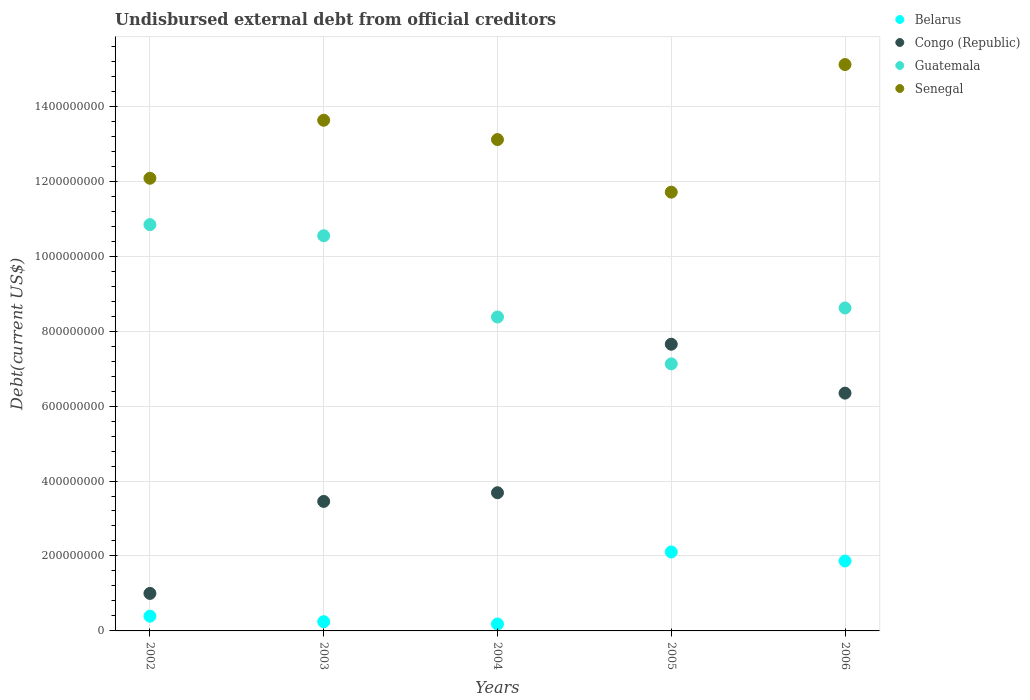How many different coloured dotlines are there?
Provide a short and direct response. 4. Is the number of dotlines equal to the number of legend labels?
Offer a terse response. Yes. What is the total debt in Belarus in 2003?
Ensure brevity in your answer.  2.46e+07. Across all years, what is the maximum total debt in Guatemala?
Offer a terse response. 1.08e+09. Across all years, what is the minimum total debt in Senegal?
Your answer should be compact. 1.17e+09. In which year was the total debt in Belarus minimum?
Your answer should be very brief. 2004. What is the total total debt in Senegal in the graph?
Offer a terse response. 6.56e+09. What is the difference between the total debt in Belarus in 2005 and that in 2006?
Make the answer very short. 2.41e+07. What is the difference between the total debt in Belarus in 2006 and the total debt in Senegal in 2005?
Provide a short and direct response. -9.84e+08. What is the average total debt in Congo (Republic) per year?
Keep it short and to the point. 4.43e+08. In the year 2006, what is the difference between the total debt in Guatemala and total debt in Senegal?
Make the answer very short. -6.50e+08. What is the ratio of the total debt in Guatemala in 2004 to that in 2006?
Your response must be concise. 0.97. What is the difference between the highest and the second highest total debt in Congo (Republic)?
Provide a succinct answer. 1.31e+08. What is the difference between the highest and the lowest total debt in Guatemala?
Offer a terse response. 3.71e+08. Is the sum of the total debt in Congo (Republic) in 2003 and 2004 greater than the maximum total debt in Senegal across all years?
Offer a very short reply. No. Is it the case that in every year, the sum of the total debt in Guatemala and total debt in Senegal  is greater than the sum of total debt in Belarus and total debt in Congo (Republic)?
Your answer should be very brief. No. Are the values on the major ticks of Y-axis written in scientific E-notation?
Your answer should be very brief. No. Does the graph contain grids?
Offer a very short reply. Yes. Where does the legend appear in the graph?
Provide a succinct answer. Top right. How are the legend labels stacked?
Provide a short and direct response. Vertical. What is the title of the graph?
Provide a succinct answer. Undisbursed external debt from official creditors. What is the label or title of the Y-axis?
Offer a terse response. Debt(current US$). What is the Debt(current US$) in Belarus in 2002?
Provide a short and direct response. 3.94e+07. What is the Debt(current US$) in Congo (Republic) in 2002?
Keep it short and to the point. 1.00e+08. What is the Debt(current US$) in Guatemala in 2002?
Offer a terse response. 1.08e+09. What is the Debt(current US$) of Senegal in 2002?
Offer a terse response. 1.21e+09. What is the Debt(current US$) in Belarus in 2003?
Provide a succinct answer. 2.46e+07. What is the Debt(current US$) of Congo (Republic) in 2003?
Make the answer very short. 3.46e+08. What is the Debt(current US$) of Guatemala in 2003?
Provide a succinct answer. 1.05e+09. What is the Debt(current US$) of Senegal in 2003?
Your response must be concise. 1.36e+09. What is the Debt(current US$) in Belarus in 2004?
Provide a short and direct response. 1.84e+07. What is the Debt(current US$) of Congo (Republic) in 2004?
Provide a short and direct response. 3.69e+08. What is the Debt(current US$) in Guatemala in 2004?
Provide a succinct answer. 8.38e+08. What is the Debt(current US$) of Senegal in 2004?
Offer a terse response. 1.31e+09. What is the Debt(current US$) of Belarus in 2005?
Give a very brief answer. 2.11e+08. What is the Debt(current US$) of Congo (Republic) in 2005?
Your response must be concise. 7.65e+08. What is the Debt(current US$) in Guatemala in 2005?
Make the answer very short. 7.13e+08. What is the Debt(current US$) of Senegal in 2005?
Provide a succinct answer. 1.17e+09. What is the Debt(current US$) in Belarus in 2006?
Your answer should be very brief. 1.87e+08. What is the Debt(current US$) in Congo (Republic) in 2006?
Give a very brief answer. 6.35e+08. What is the Debt(current US$) of Guatemala in 2006?
Ensure brevity in your answer.  8.62e+08. What is the Debt(current US$) in Senegal in 2006?
Your answer should be very brief. 1.51e+09. Across all years, what is the maximum Debt(current US$) in Belarus?
Offer a very short reply. 2.11e+08. Across all years, what is the maximum Debt(current US$) of Congo (Republic)?
Your response must be concise. 7.65e+08. Across all years, what is the maximum Debt(current US$) in Guatemala?
Ensure brevity in your answer.  1.08e+09. Across all years, what is the maximum Debt(current US$) in Senegal?
Give a very brief answer. 1.51e+09. Across all years, what is the minimum Debt(current US$) in Belarus?
Ensure brevity in your answer.  1.84e+07. Across all years, what is the minimum Debt(current US$) in Congo (Republic)?
Your answer should be very brief. 1.00e+08. Across all years, what is the minimum Debt(current US$) of Guatemala?
Give a very brief answer. 7.13e+08. Across all years, what is the minimum Debt(current US$) of Senegal?
Provide a short and direct response. 1.17e+09. What is the total Debt(current US$) in Belarus in the graph?
Your response must be concise. 4.80e+08. What is the total Debt(current US$) of Congo (Republic) in the graph?
Your answer should be compact. 2.21e+09. What is the total Debt(current US$) in Guatemala in the graph?
Your answer should be compact. 4.55e+09. What is the total Debt(current US$) of Senegal in the graph?
Keep it short and to the point. 6.56e+09. What is the difference between the Debt(current US$) of Belarus in 2002 and that in 2003?
Your answer should be compact. 1.48e+07. What is the difference between the Debt(current US$) in Congo (Republic) in 2002 and that in 2003?
Your response must be concise. -2.45e+08. What is the difference between the Debt(current US$) of Guatemala in 2002 and that in 2003?
Offer a very short reply. 2.96e+07. What is the difference between the Debt(current US$) of Senegal in 2002 and that in 2003?
Offer a very short reply. -1.55e+08. What is the difference between the Debt(current US$) of Belarus in 2002 and that in 2004?
Provide a short and direct response. 2.10e+07. What is the difference between the Debt(current US$) in Congo (Republic) in 2002 and that in 2004?
Provide a succinct answer. -2.69e+08. What is the difference between the Debt(current US$) in Guatemala in 2002 and that in 2004?
Give a very brief answer. 2.46e+08. What is the difference between the Debt(current US$) of Senegal in 2002 and that in 2004?
Ensure brevity in your answer.  -1.03e+08. What is the difference between the Debt(current US$) in Belarus in 2002 and that in 2005?
Ensure brevity in your answer.  -1.71e+08. What is the difference between the Debt(current US$) of Congo (Republic) in 2002 and that in 2005?
Your response must be concise. -6.65e+08. What is the difference between the Debt(current US$) of Guatemala in 2002 and that in 2005?
Your response must be concise. 3.71e+08. What is the difference between the Debt(current US$) of Senegal in 2002 and that in 2005?
Provide a short and direct response. 3.71e+07. What is the difference between the Debt(current US$) in Belarus in 2002 and that in 2006?
Offer a very short reply. -1.47e+08. What is the difference between the Debt(current US$) of Congo (Republic) in 2002 and that in 2006?
Your answer should be very brief. -5.34e+08. What is the difference between the Debt(current US$) in Guatemala in 2002 and that in 2006?
Make the answer very short. 2.22e+08. What is the difference between the Debt(current US$) in Senegal in 2002 and that in 2006?
Provide a short and direct response. -3.03e+08. What is the difference between the Debt(current US$) of Belarus in 2003 and that in 2004?
Offer a terse response. 6.18e+06. What is the difference between the Debt(current US$) of Congo (Republic) in 2003 and that in 2004?
Your answer should be very brief. -2.32e+07. What is the difference between the Debt(current US$) in Guatemala in 2003 and that in 2004?
Provide a succinct answer. 2.17e+08. What is the difference between the Debt(current US$) of Senegal in 2003 and that in 2004?
Keep it short and to the point. 5.16e+07. What is the difference between the Debt(current US$) of Belarus in 2003 and that in 2005?
Provide a succinct answer. -1.86e+08. What is the difference between the Debt(current US$) of Congo (Republic) in 2003 and that in 2005?
Give a very brief answer. -4.19e+08. What is the difference between the Debt(current US$) in Guatemala in 2003 and that in 2005?
Offer a very short reply. 3.42e+08. What is the difference between the Debt(current US$) of Senegal in 2003 and that in 2005?
Give a very brief answer. 1.92e+08. What is the difference between the Debt(current US$) in Belarus in 2003 and that in 2006?
Ensure brevity in your answer.  -1.62e+08. What is the difference between the Debt(current US$) of Congo (Republic) in 2003 and that in 2006?
Ensure brevity in your answer.  -2.89e+08. What is the difference between the Debt(current US$) of Guatemala in 2003 and that in 2006?
Offer a terse response. 1.93e+08. What is the difference between the Debt(current US$) of Senegal in 2003 and that in 2006?
Provide a succinct answer. -1.49e+08. What is the difference between the Debt(current US$) of Belarus in 2004 and that in 2005?
Provide a succinct answer. -1.92e+08. What is the difference between the Debt(current US$) in Congo (Republic) in 2004 and that in 2005?
Offer a very short reply. -3.96e+08. What is the difference between the Debt(current US$) in Guatemala in 2004 and that in 2005?
Keep it short and to the point. 1.25e+08. What is the difference between the Debt(current US$) of Senegal in 2004 and that in 2005?
Your response must be concise. 1.40e+08. What is the difference between the Debt(current US$) in Belarus in 2004 and that in 2006?
Your answer should be very brief. -1.68e+08. What is the difference between the Debt(current US$) of Congo (Republic) in 2004 and that in 2006?
Your answer should be very brief. -2.66e+08. What is the difference between the Debt(current US$) in Guatemala in 2004 and that in 2006?
Give a very brief answer. -2.40e+07. What is the difference between the Debt(current US$) in Senegal in 2004 and that in 2006?
Your response must be concise. -2.00e+08. What is the difference between the Debt(current US$) in Belarus in 2005 and that in 2006?
Offer a terse response. 2.41e+07. What is the difference between the Debt(current US$) of Congo (Republic) in 2005 and that in 2006?
Your answer should be compact. 1.31e+08. What is the difference between the Debt(current US$) in Guatemala in 2005 and that in 2006?
Provide a short and direct response. -1.49e+08. What is the difference between the Debt(current US$) of Senegal in 2005 and that in 2006?
Offer a very short reply. -3.40e+08. What is the difference between the Debt(current US$) in Belarus in 2002 and the Debt(current US$) in Congo (Republic) in 2003?
Offer a very short reply. -3.06e+08. What is the difference between the Debt(current US$) of Belarus in 2002 and the Debt(current US$) of Guatemala in 2003?
Offer a terse response. -1.02e+09. What is the difference between the Debt(current US$) of Belarus in 2002 and the Debt(current US$) of Senegal in 2003?
Provide a succinct answer. -1.32e+09. What is the difference between the Debt(current US$) in Congo (Republic) in 2002 and the Debt(current US$) in Guatemala in 2003?
Your answer should be very brief. -9.54e+08. What is the difference between the Debt(current US$) in Congo (Republic) in 2002 and the Debt(current US$) in Senegal in 2003?
Ensure brevity in your answer.  -1.26e+09. What is the difference between the Debt(current US$) of Guatemala in 2002 and the Debt(current US$) of Senegal in 2003?
Your answer should be compact. -2.79e+08. What is the difference between the Debt(current US$) in Belarus in 2002 and the Debt(current US$) in Congo (Republic) in 2004?
Offer a terse response. -3.29e+08. What is the difference between the Debt(current US$) in Belarus in 2002 and the Debt(current US$) in Guatemala in 2004?
Your answer should be very brief. -7.98e+08. What is the difference between the Debt(current US$) in Belarus in 2002 and the Debt(current US$) in Senegal in 2004?
Provide a succinct answer. -1.27e+09. What is the difference between the Debt(current US$) in Congo (Republic) in 2002 and the Debt(current US$) in Guatemala in 2004?
Your answer should be compact. -7.38e+08. What is the difference between the Debt(current US$) of Congo (Republic) in 2002 and the Debt(current US$) of Senegal in 2004?
Your answer should be very brief. -1.21e+09. What is the difference between the Debt(current US$) of Guatemala in 2002 and the Debt(current US$) of Senegal in 2004?
Keep it short and to the point. -2.27e+08. What is the difference between the Debt(current US$) in Belarus in 2002 and the Debt(current US$) in Congo (Republic) in 2005?
Your answer should be very brief. -7.26e+08. What is the difference between the Debt(current US$) of Belarus in 2002 and the Debt(current US$) of Guatemala in 2005?
Offer a terse response. -6.73e+08. What is the difference between the Debt(current US$) in Belarus in 2002 and the Debt(current US$) in Senegal in 2005?
Your answer should be very brief. -1.13e+09. What is the difference between the Debt(current US$) in Congo (Republic) in 2002 and the Debt(current US$) in Guatemala in 2005?
Make the answer very short. -6.13e+08. What is the difference between the Debt(current US$) of Congo (Republic) in 2002 and the Debt(current US$) of Senegal in 2005?
Offer a very short reply. -1.07e+09. What is the difference between the Debt(current US$) of Guatemala in 2002 and the Debt(current US$) of Senegal in 2005?
Your response must be concise. -8.67e+07. What is the difference between the Debt(current US$) in Belarus in 2002 and the Debt(current US$) in Congo (Republic) in 2006?
Ensure brevity in your answer.  -5.95e+08. What is the difference between the Debt(current US$) in Belarus in 2002 and the Debt(current US$) in Guatemala in 2006?
Keep it short and to the point. -8.22e+08. What is the difference between the Debt(current US$) in Belarus in 2002 and the Debt(current US$) in Senegal in 2006?
Ensure brevity in your answer.  -1.47e+09. What is the difference between the Debt(current US$) in Congo (Republic) in 2002 and the Debt(current US$) in Guatemala in 2006?
Keep it short and to the point. -7.62e+08. What is the difference between the Debt(current US$) of Congo (Republic) in 2002 and the Debt(current US$) of Senegal in 2006?
Your response must be concise. -1.41e+09. What is the difference between the Debt(current US$) in Guatemala in 2002 and the Debt(current US$) in Senegal in 2006?
Your response must be concise. -4.27e+08. What is the difference between the Debt(current US$) of Belarus in 2003 and the Debt(current US$) of Congo (Republic) in 2004?
Ensure brevity in your answer.  -3.44e+08. What is the difference between the Debt(current US$) of Belarus in 2003 and the Debt(current US$) of Guatemala in 2004?
Ensure brevity in your answer.  -8.13e+08. What is the difference between the Debt(current US$) of Belarus in 2003 and the Debt(current US$) of Senegal in 2004?
Offer a very short reply. -1.29e+09. What is the difference between the Debt(current US$) in Congo (Republic) in 2003 and the Debt(current US$) in Guatemala in 2004?
Your answer should be very brief. -4.92e+08. What is the difference between the Debt(current US$) of Congo (Republic) in 2003 and the Debt(current US$) of Senegal in 2004?
Your response must be concise. -9.66e+08. What is the difference between the Debt(current US$) of Guatemala in 2003 and the Debt(current US$) of Senegal in 2004?
Offer a terse response. -2.57e+08. What is the difference between the Debt(current US$) in Belarus in 2003 and the Debt(current US$) in Congo (Republic) in 2005?
Make the answer very short. -7.40e+08. What is the difference between the Debt(current US$) of Belarus in 2003 and the Debt(current US$) of Guatemala in 2005?
Offer a very short reply. -6.88e+08. What is the difference between the Debt(current US$) of Belarus in 2003 and the Debt(current US$) of Senegal in 2005?
Provide a succinct answer. -1.15e+09. What is the difference between the Debt(current US$) of Congo (Republic) in 2003 and the Debt(current US$) of Guatemala in 2005?
Offer a terse response. -3.67e+08. What is the difference between the Debt(current US$) in Congo (Republic) in 2003 and the Debt(current US$) in Senegal in 2005?
Give a very brief answer. -8.25e+08. What is the difference between the Debt(current US$) in Guatemala in 2003 and the Debt(current US$) in Senegal in 2005?
Ensure brevity in your answer.  -1.16e+08. What is the difference between the Debt(current US$) in Belarus in 2003 and the Debt(current US$) in Congo (Republic) in 2006?
Offer a very short reply. -6.10e+08. What is the difference between the Debt(current US$) in Belarus in 2003 and the Debt(current US$) in Guatemala in 2006?
Your answer should be compact. -8.37e+08. What is the difference between the Debt(current US$) of Belarus in 2003 and the Debt(current US$) of Senegal in 2006?
Your answer should be compact. -1.49e+09. What is the difference between the Debt(current US$) of Congo (Republic) in 2003 and the Debt(current US$) of Guatemala in 2006?
Make the answer very short. -5.16e+08. What is the difference between the Debt(current US$) in Congo (Republic) in 2003 and the Debt(current US$) in Senegal in 2006?
Make the answer very short. -1.17e+09. What is the difference between the Debt(current US$) of Guatemala in 2003 and the Debt(current US$) of Senegal in 2006?
Keep it short and to the point. -4.57e+08. What is the difference between the Debt(current US$) in Belarus in 2004 and the Debt(current US$) in Congo (Republic) in 2005?
Your response must be concise. -7.47e+08. What is the difference between the Debt(current US$) of Belarus in 2004 and the Debt(current US$) of Guatemala in 2005?
Provide a succinct answer. -6.94e+08. What is the difference between the Debt(current US$) in Belarus in 2004 and the Debt(current US$) in Senegal in 2005?
Keep it short and to the point. -1.15e+09. What is the difference between the Debt(current US$) in Congo (Republic) in 2004 and the Debt(current US$) in Guatemala in 2005?
Offer a terse response. -3.44e+08. What is the difference between the Debt(current US$) in Congo (Republic) in 2004 and the Debt(current US$) in Senegal in 2005?
Your answer should be very brief. -8.02e+08. What is the difference between the Debt(current US$) of Guatemala in 2004 and the Debt(current US$) of Senegal in 2005?
Offer a terse response. -3.33e+08. What is the difference between the Debt(current US$) of Belarus in 2004 and the Debt(current US$) of Congo (Republic) in 2006?
Your answer should be very brief. -6.16e+08. What is the difference between the Debt(current US$) in Belarus in 2004 and the Debt(current US$) in Guatemala in 2006?
Keep it short and to the point. -8.43e+08. What is the difference between the Debt(current US$) of Belarus in 2004 and the Debt(current US$) of Senegal in 2006?
Keep it short and to the point. -1.49e+09. What is the difference between the Debt(current US$) of Congo (Republic) in 2004 and the Debt(current US$) of Guatemala in 2006?
Provide a short and direct response. -4.93e+08. What is the difference between the Debt(current US$) in Congo (Republic) in 2004 and the Debt(current US$) in Senegal in 2006?
Your answer should be compact. -1.14e+09. What is the difference between the Debt(current US$) in Guatemala in 2004 and the Debt(current US$) in Senegal in 2006?
Offer a terse response. -6.74e+08. What is the difference between the Debt(current US$) in Belarus in 2005 and the Debt(current US$) in Congo (Republic) in 2006?
Ensure brevity in your answer.  -4.24e+08. What is the difference between the Debt(current US$) in Belarus in 2005 and the Debt(current US$) in Guatemala in 2006?
Provide a succinct answer. -6.51e+08. What is the difference between the Debt(current US$) of Belarus in 2005 and the Debt(current US$) of Senegal in 2006?
Offer a very short reply. -1.30e+09. What is the difference between the Debt(current US$) of Congo (Republic) in 2005 and the Debt(current US$) of Guatemala in 2006?
Offer a terse response. -9.67e+07. What is the difference between the Debt(current US$) of Congo (Republic) in 2005 and the Debt(current US$) of Senegal in 2006?
Provide a short and direct response. -7.46e+08. What is the difference between the Debt(current US$) in Guatemala in 2005 and the Debt(current US$) in Senegal in 2006?
Your answer should be compact. -7.99e+08. What is the average Debt(current US$) of Belarus per year?
Provide a short and direct response. 9.59e+07. What is the average Debt(current US$) of Congo (Republic) per year?
Provide a succinct answer. 4.43e+08. What is the average Debt(current US$) of Guatemala per year?
Offer a very short reply. 9.10e+08. What is the average Debt(current US$) in Senegal per year?
Offer a terse response. 1.31e+09. In the year 2002, what is the difference between the Debt(current US$) of Belarus and Debt(current US$) of Congo (Republic)?
Provide a succinct answer. -6.07e+07. In the year 2002, what is the difference between the Debt(current US$) in Belarus and Debt(current US$) in Guatemala?
Provide a succinct answer. -1.04e+09. In the year 2002, what is the difference between the Debt(current US$) of Belarus and Debt(current US$) of Senegal?
Provide a short and direct response. -1.17e+09. In the year 2002, what is the difference between the Debt(current US$) of Congo (Republic) and Debt(current US$) of Guatemala?
Make the answer very short. -9.84e+08. In the year 2002, what is the difference between the Debt(current US$) of Congo (Republic) and Debt(current US$) of Senegal?
Your answer should be compact. -1.11e+09. In the year 2002, what is the difference between the Debt(current US$) in Guatemala and Debt(current US$) in Senegal?
Offer a terse response. -1.24e+08. In the year 2003, what is the difference between the Debt(current US$) of Belarus and Debt(current US$) of Congo (Republic)?
Offer a terse response. -3.21e+08. In the year 2003, what is the difference between the Debt(current US$) in Belarus and Debt(current US$) in Guatemala?
Your response must be concise. -1.03e+09. In the year 2003, what is the difference between the Debt(current US$) in Belarus and Debt(current US$) in Senegal?
Provide a succinct answer. -1.34e+09. In the year 2003, what is the difference between the Debt(current US$) in Congo (Republic) and Debt(current US$) in Guatemala?
Ensure brevity in your answer.  -7.09e+08. In the year 2003, what is the difference between the Debt(current US$) in Congo (Republic) and Debt(current US$) in Senegal?
Your answer should be very brief. -1.02e+09. In the year 2003, what is the difference between the Debt(current US$) in Guatemala and Debt(current US$) in Senegal?
Provide a short and direct response. -3.08e+08. In the year 2004, what is the difference between the Debt(current US$) in Belarus and Debt(current US$) in Congo (Republic)?
Keep it short and to the point. -3.50e+08. In the year 2004, what is the difference between the Debt(current US$) of Belarus and Debt(current US$) of Guatemala?
Offer a very short reply. -8.19e+08. In the year 2004, what is the difference between the Debt(current US$) of Belarus and Debt(current US$) of Senegal?
Offer a terse response. -1.29e+09. In the year 2004, what is the difference between the Debt(current US$) of Congo (Republic) and Debt(current US$) of Guatemala?
Make the answer very short. -4.69e+08. In the year 2004, what is the difference between the Debt(current US$) in Congo (Republic) and Debt(current US$) in Senegal?
Your response must be concise. -9.42e+08. In the year 2004, what is the difference between the Debt(current US$) in Guatemala and Debt(current US$) in Senegal?
Your response must be concise. -4.73e+08. In the year 2005, what is the difference between the Debt(current US$) of Belarus and Debt(current US$) of Congo (Republic)?
Make the answer very short. -5.54e+08. In the year 2005, what is the difference between the Debt(current US$) of Belarus and Debt(current US$) of Guatemala?
Offer a terse response. -5.02e+08. In the year 2005, what is the difference between the Debt(current US$) in Belarus and Debt(current US$) in Senegal?
Ensure brevity in your answer.  -9.60e+08. In the year 2005, what is the difference between the Debt(current US$) in Congo (Republic) and Debt(current US$) in Guatemala?
Ensure brevity in your answer.  5.24e+07. In the year 2005, what is the difference between the Debt(current US$) in Congo (Republic) and Debt(current US$) in Senegal?
Your response must be concise. -4.06e+08. In the year 2005, what is the difference between the Debt(current US$) in Guatemala and Debt(current US$) in Senegal?
Provide a short and direct response. -4.58e+08. In the year 2006, what is the difference between the Debt(current US$) in Belarus and Debt(current US$) in Congo (Republic)?
Provide a succinct answer. -4.48e+08. In the year 2006, what is the difference between the Debt(current US$) of Belarus and Debt(current US$) of Guatemala?
Your answer should be very brief. -6.75e+08. In the year 2006, what is the difference between the Debt(current US$) in Belarus and Debt(current US$) in Senegal?
Your response must be concise. -1.32e+09. In the year 2006, what is the difference between the Debt(current US$) in Congo (Republic) and Debt(current US$) in Guatemala?
Your answer should be compact. -2.27e+08. In the year 2006, what is the difference between the Debt(current US$) in Congo (Republic) and Debt(current US$) in Senegal?
Provide a short and direct response. -8.77e+08. In the year 2006, what is the difference between the Debt(current US$) of Guatemala and Debt(current US$) of Senegal?
Make the answer very short. -6.50e+08. What is the ratio of the Debt(current US$) in Belarus in 2002 to that in 2003?
Provide a succinct answer. 1.6. What is the ratio of the Debt(current US$) of Congo (Republic) in 2002 to that in 2003?
Make the answer very short. 0.29. What is the ratio of the Debt(current US$) in Guatemala in 2002 to that in 2003?
Your response must be concise. 1.03. What is the ratio of the Debt(current US$) in Senegal in 2002 to that in 2003?
Provide a succinct answer. 0.89. What is the ratio of the Debt(current US$) in Belarus in 2002 to that in 2004?
Keep it short and to the point. 2.14. What is the ratio of the Debt(current US$) of Congo (Republic) in 2002 to that in 2004?
Keep it short and to the point. 0.27. What is the ratio of the Debt(current US$) in Guatemala in 2002 to that in 2004?
Offer a very short reply. 1.29. What is the ratio of the Debt(current US$) in Senegal in 2002 to that in 2004?
Your response must be concise. 0.92. What is the ratio of the Debt(current US$) in Belarus in 2002 to that in 2005?
Give a very brief answer. 0.19. What is the ratio of the Debt(current US$) of Congo (Republic) in 2002 to that in 2005?
Your answer should be very brief. 0.13. What is the ratio of the Debt(current US$) in Guatemala in 2002 to that in 2005?
Your answer should be compact. 1.52. What is the ratio of the Debt(current US$) of Senegal in 2002 to that in 2005?
Provide a succinct answer. 1.03. What is the ratio of the Debt(current US$) in Belarus in 2002 to that in 2006?
Your response must be concise. 0.21. What is the ratio of the Debt(current US$) in Congo (Republic) in 2002 to that in 2006?
Ensure brevity in your answer.  0.16. What is the ratio of the Debt(current US$) in Guatemala in 2002 to that in 2006?
Your answer should be compact. 1.26. What is the ratio of the Debt(current US$) in Senegal in 2002 to that in 2006?
Your response must be concise. 0.8. What is the ratio of the Debt(current US$) of Belarus in 2003 to that in 2004?
Ensure brevity in your answer.  1.34. What is the ratio of the Debt(current US$) of Congo (Republic) in 2003 to that in 2004?
Provide a short and direct response. 0.94. What is the ratio of the Debt(current US$) in Guatemala in 2003 to that in 2004?
Make the answer very short. 1.26. What is the ratio of the Debt(current US$) of Senegal in 2003 to that in 2004?
Your answer should be very brief. 1.04. What is the ratio of the Debt(current US$) in Belarus in 2003 to that in 2005?
Keep it short and to the point. 0.12. What is the ratio of the Debt(current US$) of Congo (Republic) in 2003 to that in 2005?
Keep it short and to the point. 0.45. What is the ratio of the Debt(current US$) in Guatemala in 2003 to that in 2005?
Offer a terse response. 1.48. What is the ratio of the Debt(current US$) of Senegal in 2003 to that in 2005?
Give a very brief answer. 1.16. What is the ratio of the Debt(current US$) in Belarus in 2003 to that in 2006?
Your answer should be compact. 0.13. What is the ratio of the Debt(current US$) of Congo (Republic) in 2003 to that in 2006?
Ensure brevity in your answer.  0.54. What is the ratio of the Debt(current US$) in Guatemala in 2003 to that in 2006?
Ensure brevity in your answer.  1.22. What is the ratio of the Debt(current US$) of Senegal in 2003 to that in 2006?
Provide a succinct answer. 0.9. What is the ratio of the Debt(current US$) of Belarus in 2004 to that in 2005?
Offer a terse response. 0.09. What is the ratio of the Debt(current US$) in Congo (Republic) in 2004 to that in 2005?
Offer a terse response. 0.48. What is the ratio of the Debt(current US$) in Guatemala in 2004 to that in 2005?
Your answer should be very brief. 1.18. What is the ratio of the Debt(current US$) in Senegal in 2004 to that in 2005?
Ensure brevity in your answer.  1.12. What is the ratio of the Debt(current US$) of Belarus in 2004 to that in 2006?
Keep it short and to the point. 0.1. What is the ratio of the Debt(current US$) in Congo (Republic) in 2004 to that in 2006?
Ensure brevity in your answer.  0.58. What is the ratio of the Debt(current US$) of Guatemala in 2004 to that in 2006?
Offer a very short reply. 0.97. What is the ratio of the Debt(current US$) of Senegal in 2004 to that in 2006?
Offer a very short reply. 0.87. What is the ratio of the Debt(current US$) of Belarus in 2005 to that in 2006?
Give a very brief answer. 1.13. What is the ratio of the Debt(current US$) in Congo (Republic) in 2005 to that in 2006?
Offer a terse response. 1.21. What is the ratio of the Debt(current US$) in Guatemala in 2005 to that in 2006?
Provide a succinct answer. 0.83. What is the ratio of the Debt(current US$) of Senegal in 2005 to that in 2006?
Offer a very short reply. 0.77. What is the difference between the highest and the second highest Debt(current US$) in Belarus?
Your answer should be very brief. 2.41e+07. What is the difference between the highest and the second highest Debt(current US$) of Congo (Republic)?
Make the answer very short. 1.31e+08. What is the difference between the highest and the second highest Debt(current US$) in Guatemala?
Provide a succinct answer. 2.96e+07. What is the difference between the highest and the second highest Debt(current US$) of Senegal?
Ensure brevity in your answer.  1.49e+08. What is the difference between the highest and the lowest Debt(current US$) in Belarus?
Your answer should be compact. 1.92e+08. What is the difference between the highest and the lowest Debt(current US$) in Congo (Republic)?
Your response must be concise. 6.65e+08. What is the difference between the highest and the lowest Debt(current US$) in Guatemala?
Keep it short and to the point. 3.71e+08. What is the difference between the highest and the lowest Debt(current US$) of Senegal?
Your response must be concise. 3.40e+08. 